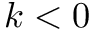<formula> <loc_0><loc_0><loc_500><loc_500>k < 0</formula> 